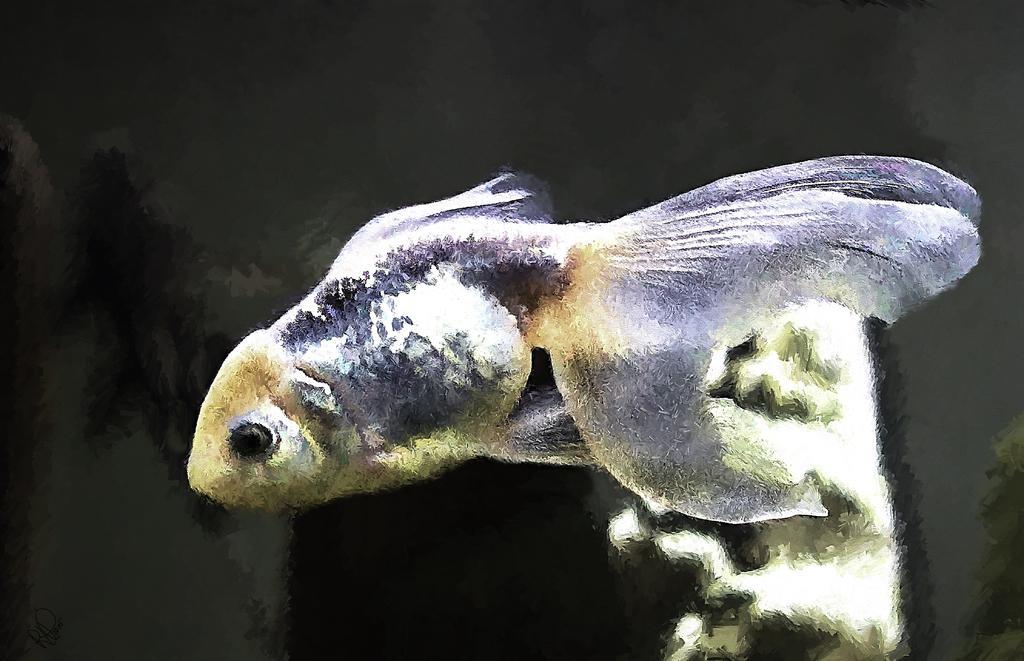Describe this image in one or two sentences. This image consists of a fish in blue color. In the background, there is water. 